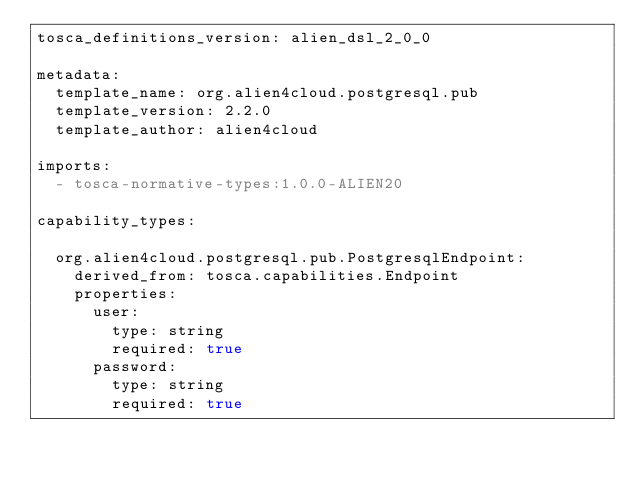<code> <loc_0><loc_0><loc_500><loc_500><_YAML_>tosca_definitions_version: alien_dsl_2_0_0

metadata:
  template_name: org.alien4cloud.postgresql.pub
  template_version: 2.2.0
  template_author: alien4cloud

imports:
  - tosca-normative-types:1.0.0-ALIEN20

capability_types:

  org.alien4cloud.postgresql.pub.PostgresqlEndpoint:
    derived_from: tosca.capabilities.Endpoint
    properties:
      user:
        type: string
        required: true
      password:
        type: string
        required: true
</code> 